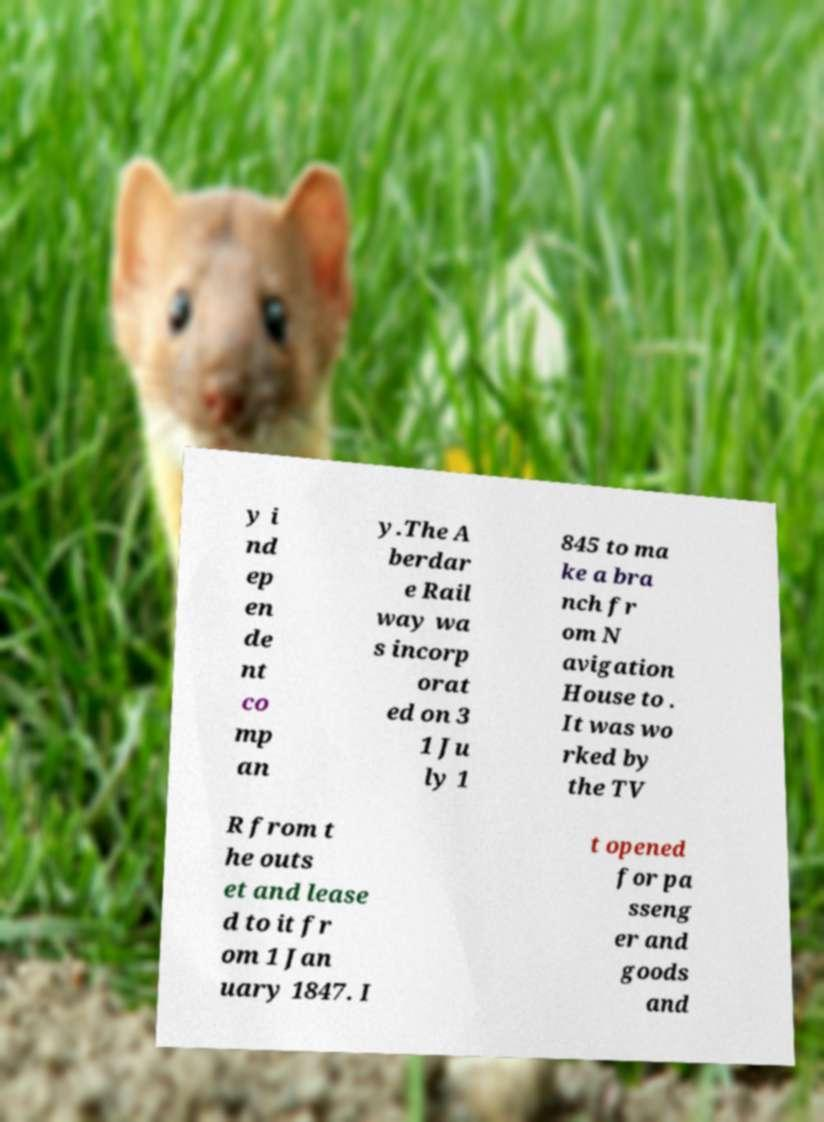Please read and relay the text visible in this image. What does it say? y i nd ep en de nt co mp an y.The A berdar e Rail way wa s incorp orat ed on 3 1 Ju ly 1 845 to ma ke a bra nch fr om N avigation House to . It was wo rked by the TV R from t he outs et and lease d to it fr om 1 Jan uary 1847. I t opened for pa sseng er and goods and 